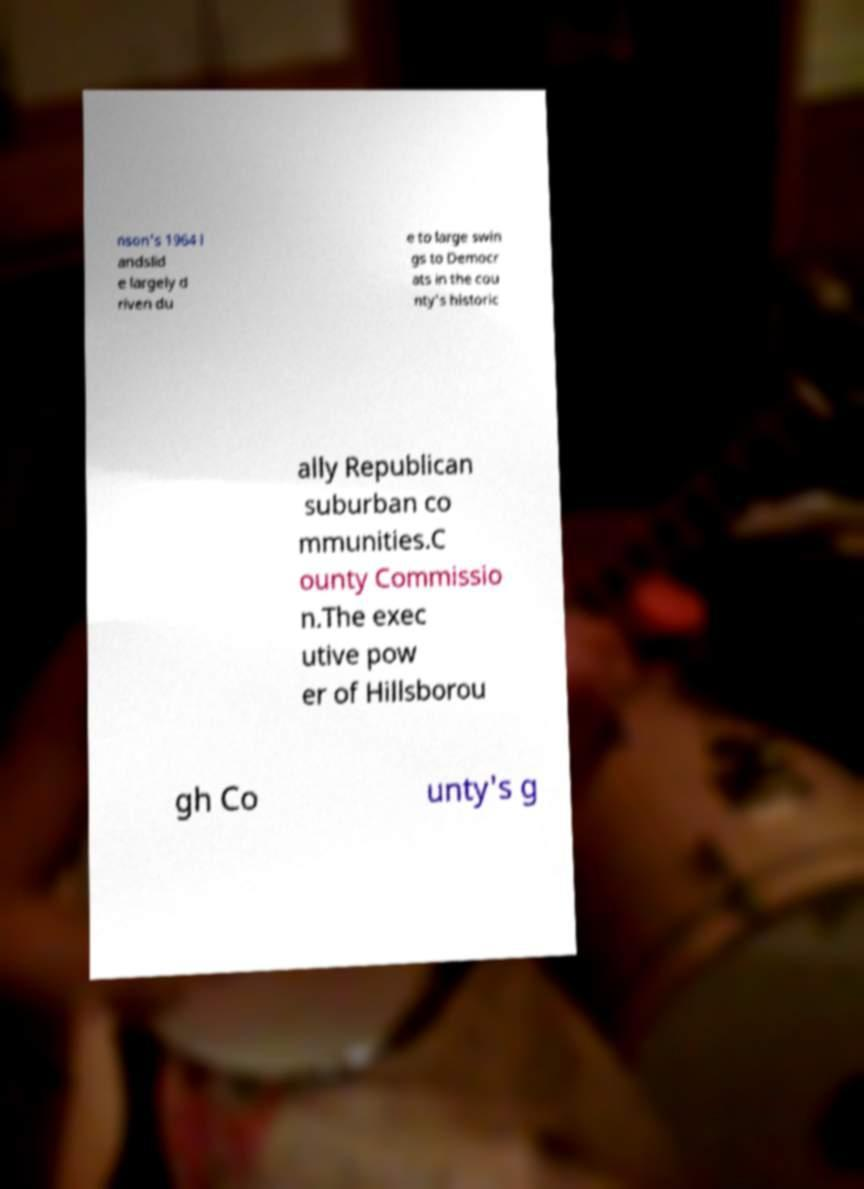There's text embedded in this image that I need extracted. Can you transcribe it verbatim? nson's 1964 l andslid e largely d riven du e to large swin gs to Democr ats in the cou nty's historic ally Republican suburban co mmunities.C ounty Commissio n.The exec utive pow er of Hillsborou gh Co unty's g 